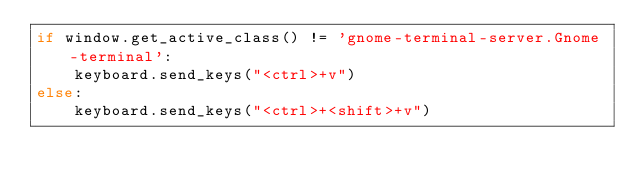<code> <loc_0><loc_0><loc_500><loc_500><_Python_>if window.get_active_class() != 'gnome-terminal-server.Gnome-terminal':
    keyboard.send_keys("<ctrl>+v")
else:
    keyboard.send_keys("<ctrl>+<shift>+v")
</code> 